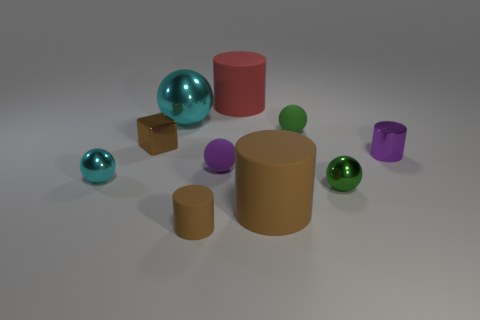Subtract all purple balls. How many balls are left? 4 Subtract 2 balls. How many balls are left? 3 Subtract all red cylinders. How many cylinders are left? 3 Subtract all red balls. Subtract all yellow cylinders. How many balls are left? 5 Subtract all blocks. How many objects are left? 9 Add 6 large spheres. How many large spheres exist? 7 Subtract 0 brown balls. How many objects are left? 10 Subtract all brown matte cylinders. Subtract all matte cylinders. How many objects are left? 5 Add 7 large things. How many large things are left? 10 